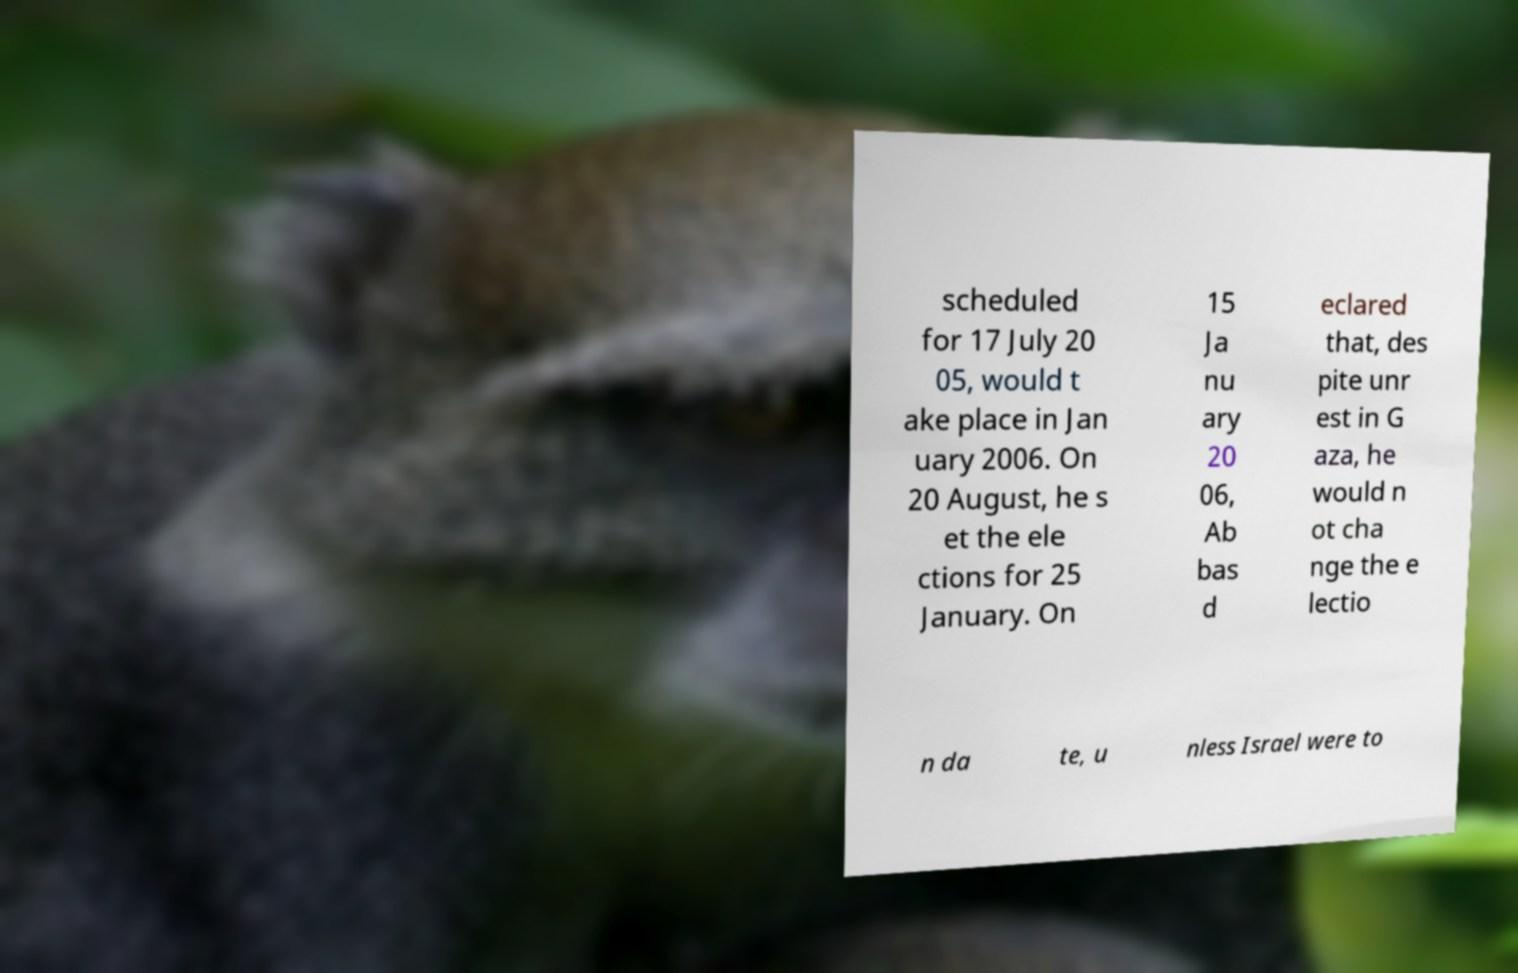Could you extract and type out the text from this image? scheduled for 17 July 20 05, would t ake place in Jan uary 2006. On 20 August, he s et the ele ctions for 25 January. On 15 Ja nu ary 20 06, Ab bas d eclared that, des pite unr est in G aza, he would n ot cha nge the e lectio n da te, u nless Israel were to 